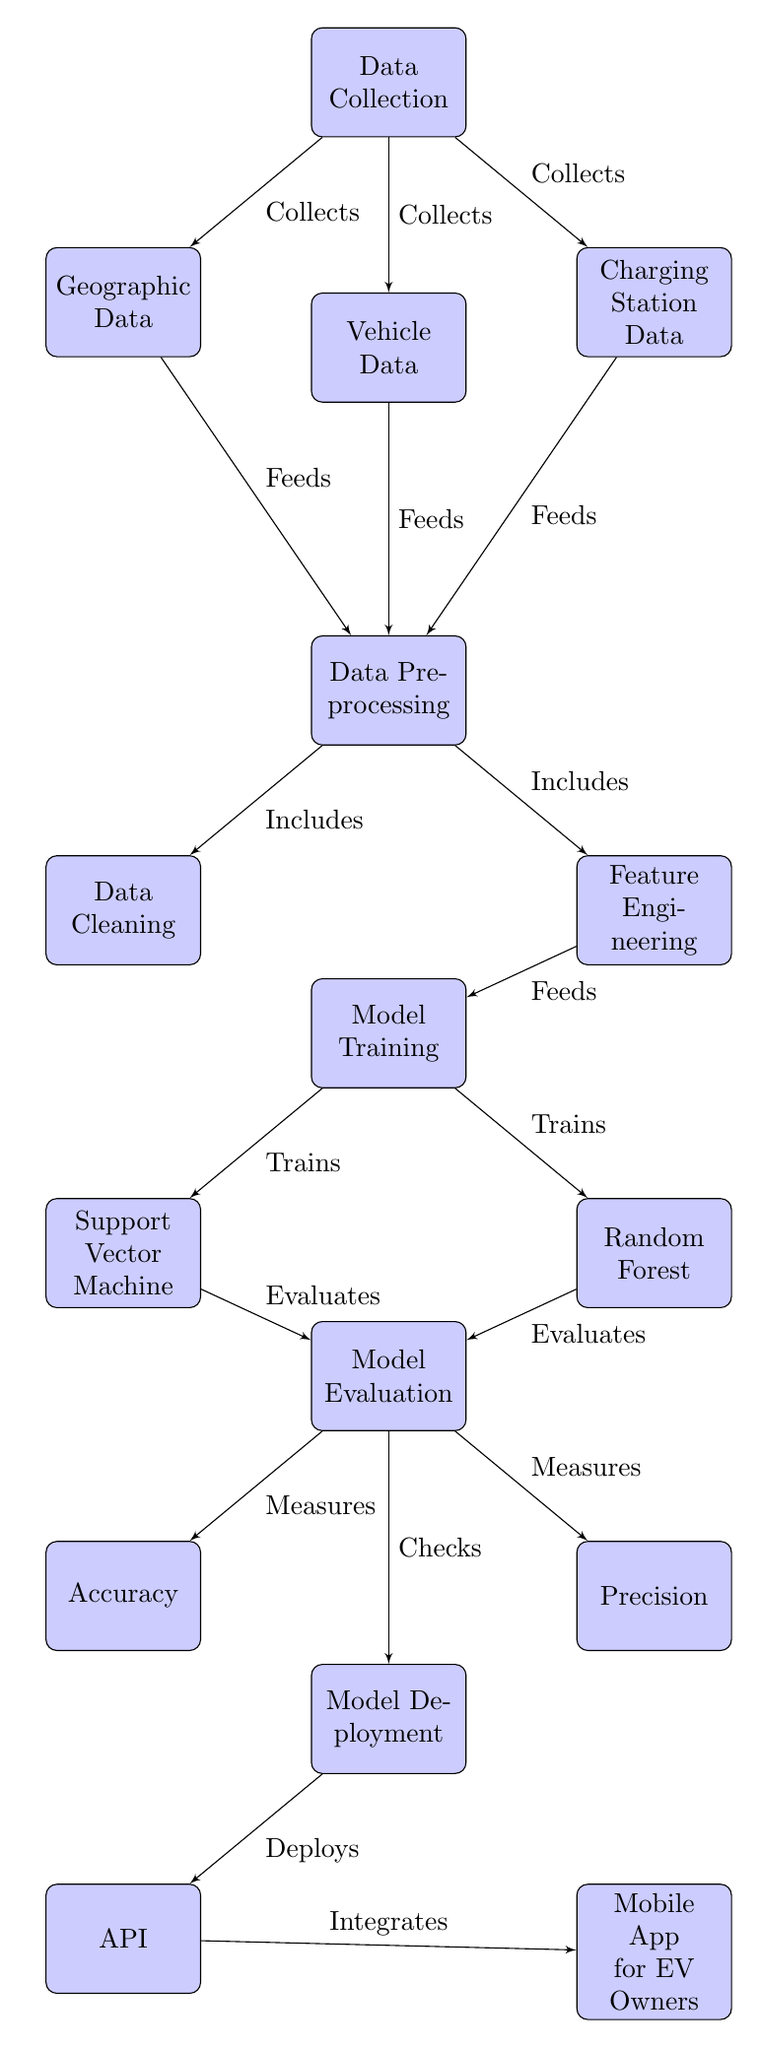What are the three types of data collected in the diagram? The diagram shows three data collection nodes labeled as Geographic Data, Vehicle Data, and Charging Station Data.
Answer: Geographic Data, Vehicle Data, Charging Station Data How many nodes are there from Data Preprocessing to Model Deployment? Moving from Data Preprocessing to Model Deployment, there are three nodes: Model Training, Model Evaluation, and Model Deployment.
Answer: Three What is the main goal of the evaluation phase in this diagram? The evaluation phase measures Accuracy and Precision as outcomes of the Model Training phase.
Answer: To measure accuracy and precision Which model is trained alongside the Support Vector Machine? The diagram indicates that Random Forest is the other model trained alongside the Support Vector Machine under Model Training.
Answer: Random Forest What does the API integrate with according to the diagram? The diagram shows that the API integrates with the Mobile App for EV Owners, indicating a connection from the API node to the Mobile App node.
Answer: Mobile App for EV Owners How does geographic data connect to the data preprocessing step? Geographic Data feeds into Data Preprocessing, as indicated by the directed edge between these nodes in the diagram.
Answer: Feeds What is the final output node of this machine learning process? The last step in the diagram is the Mobile App for EV Owners, which acts as the end result of the entire process outlined.
Answer: Mobile App for EV Owners What is the purpose of data cleaning in the overall process? Data Cleaning is a part of Data Preprocessing, which cleans and prepares data before it is used in feature engineering and model training.
Answer: To clean and prepare data How many measures are shown in the evaluation phase? The evaluation phase includes two measures, which are Accuracy and Precision according to the diagram.
Answer: Two 